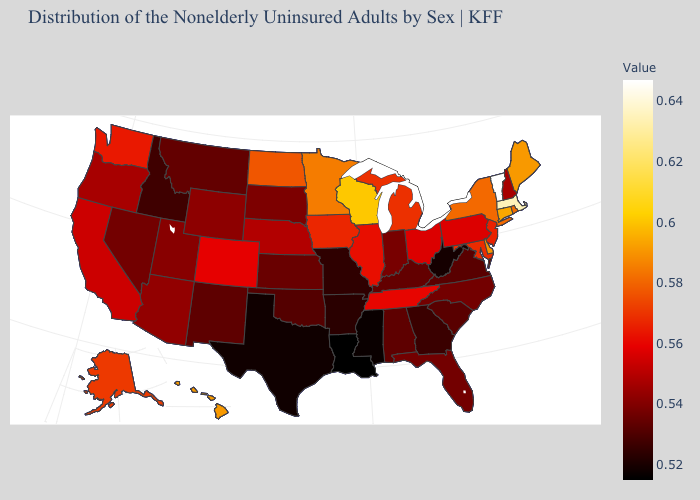Is the legend a continuous bar?
Write a very short answer. Yes. 